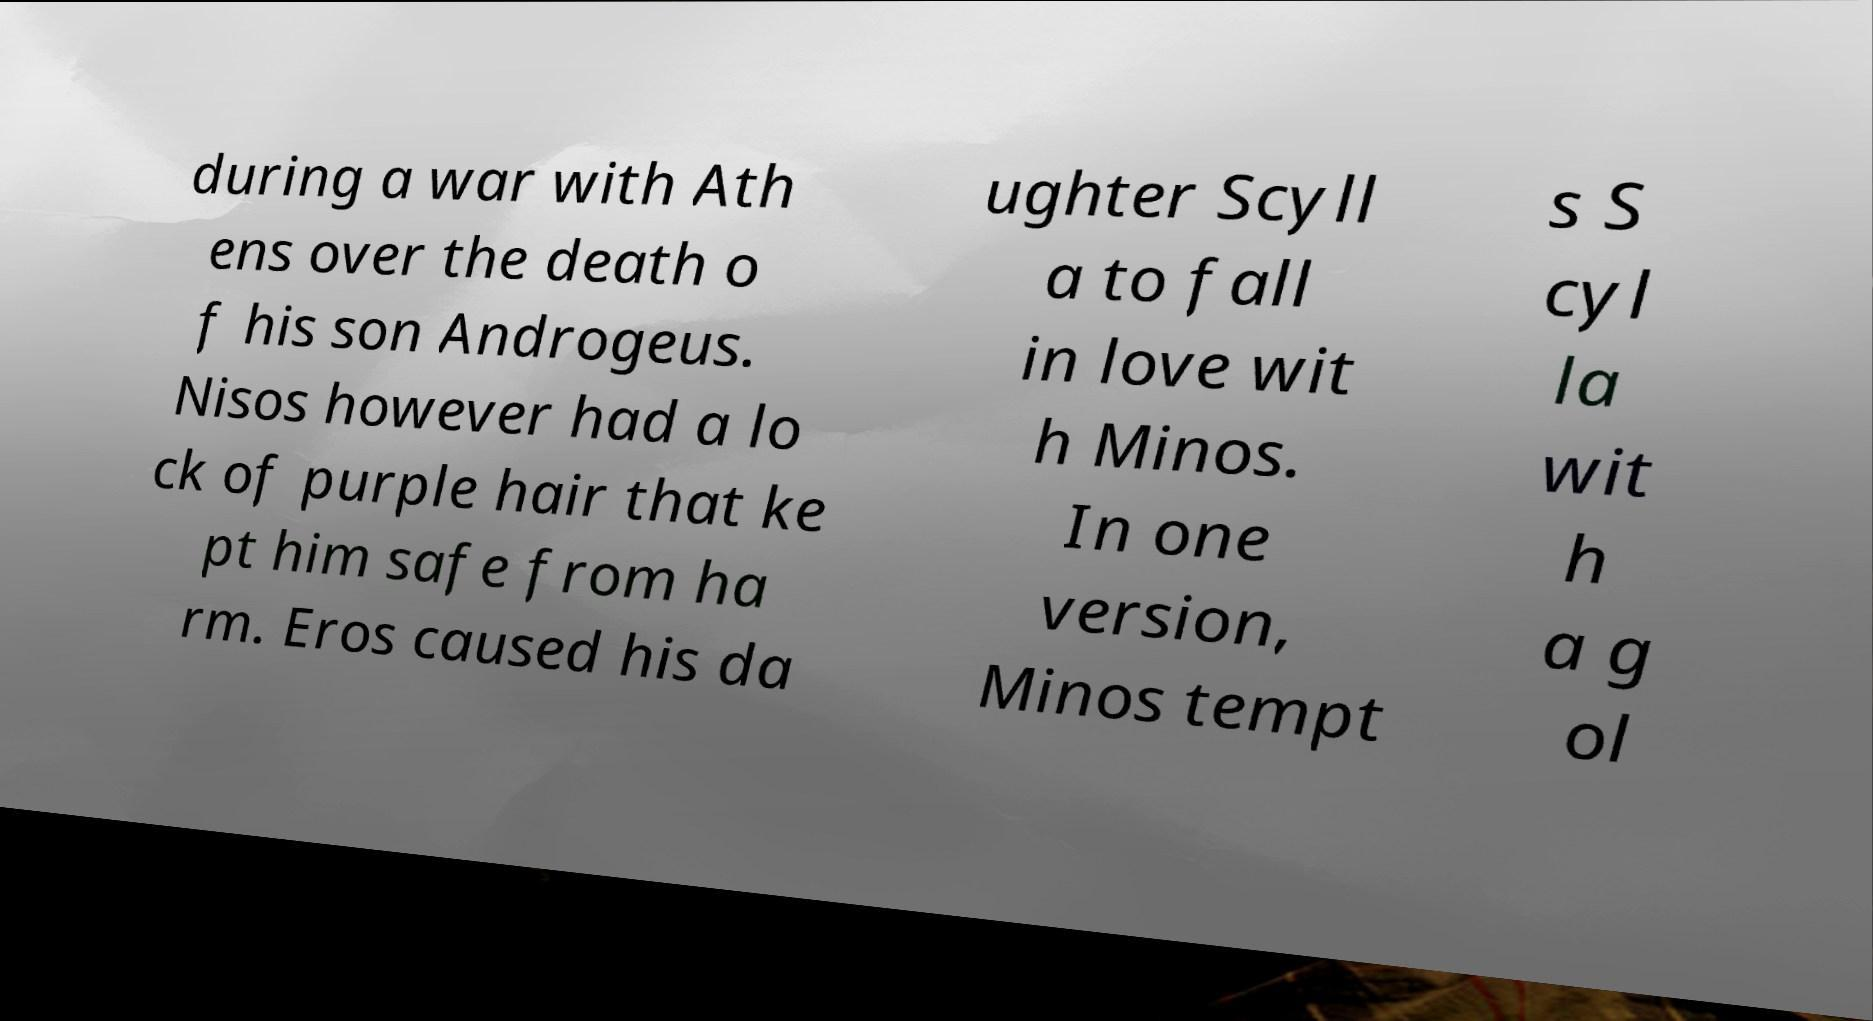There's text embedded in this image that I need extracted. Can you transcribe it verbatim? during a war with Ath ens over the death o f his son Androgeus. Nisos however had a lo ck of purple hair that ke pt him safe from ha rm. Eros caused his da ughter Scyll a to fall in love wit h Minos. In one version, Minos tempt s S cyl la wit h a g ol 